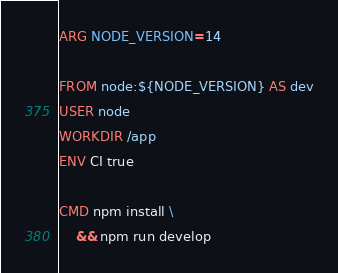<code> <loc_0><loc_0><loc_500><loc_500><_Dockerfile_>ARG NODE_VERSION=14

FROM node:${NODE_VERSION} AS dev
USER node
WORKDIR /app
ENV CI true

CMD npm install \
    && npm run develop
</code> 